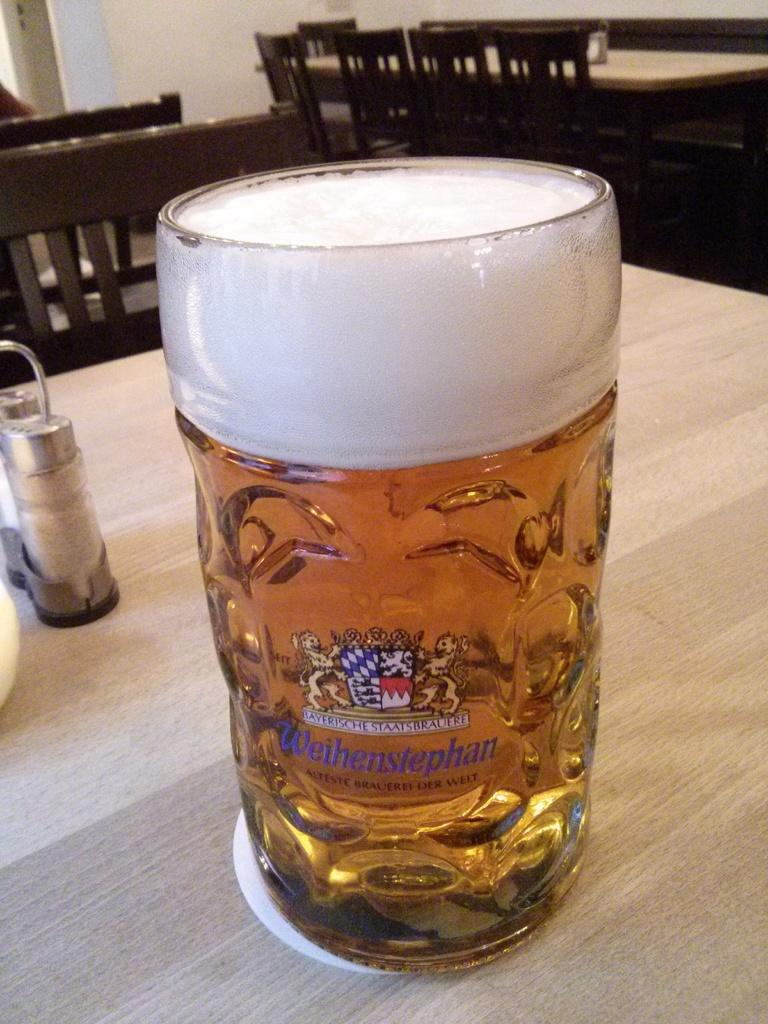What object is visible in the image? There is a glass in the image. What type of furniture can be seen in the background of the image? There are tables and chairs in the background of the image. What type of bells can be heard ringing in the image? There are no bells present in the image, and therefore no sounds can be heard. 